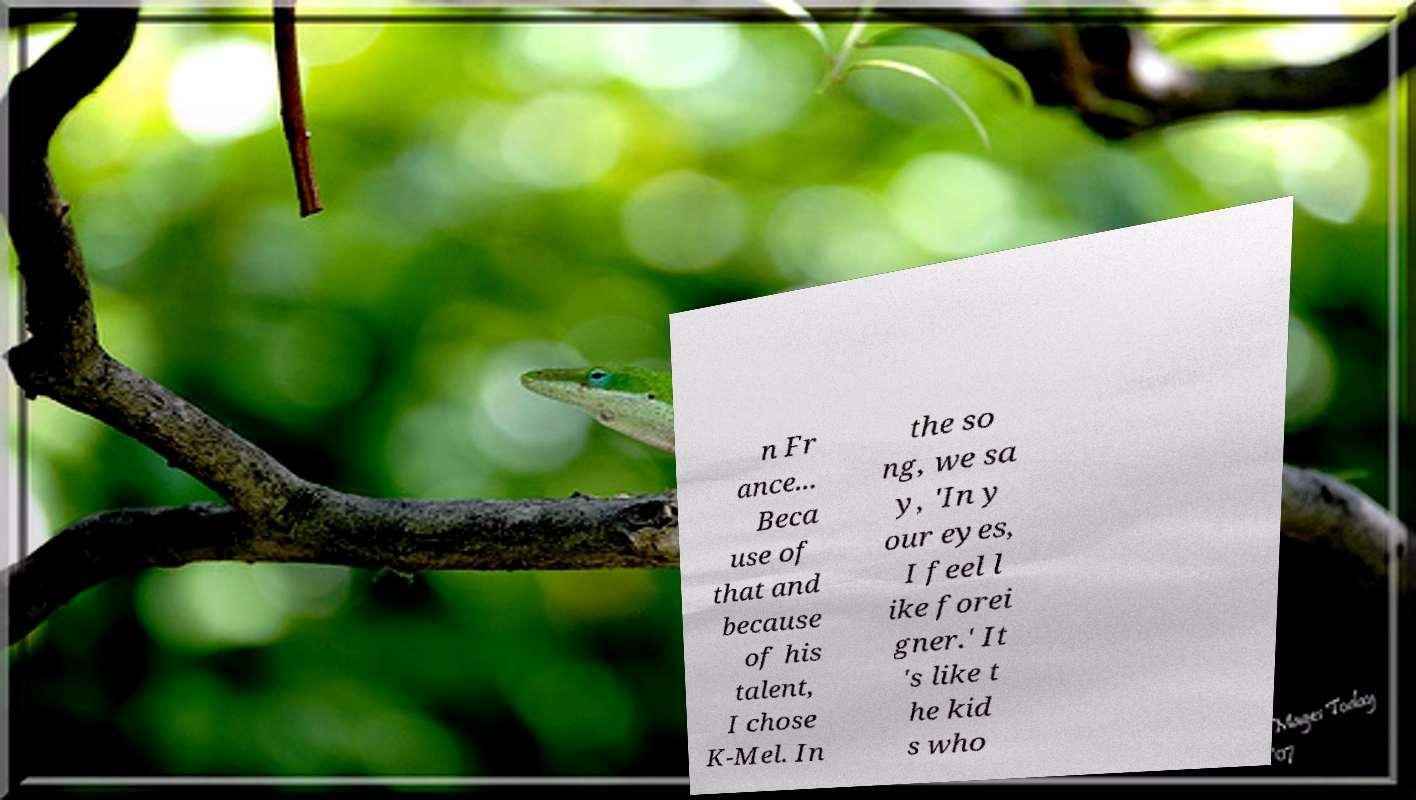Can you accurately transcribe the text from the provided image for me? n Fr ance... Beca use of that and because of his talent, I chose K-Mel. In the so ng, we sa y, 'In y our eyes, I feel l ike forei gner.' It 's like t he kid s who 